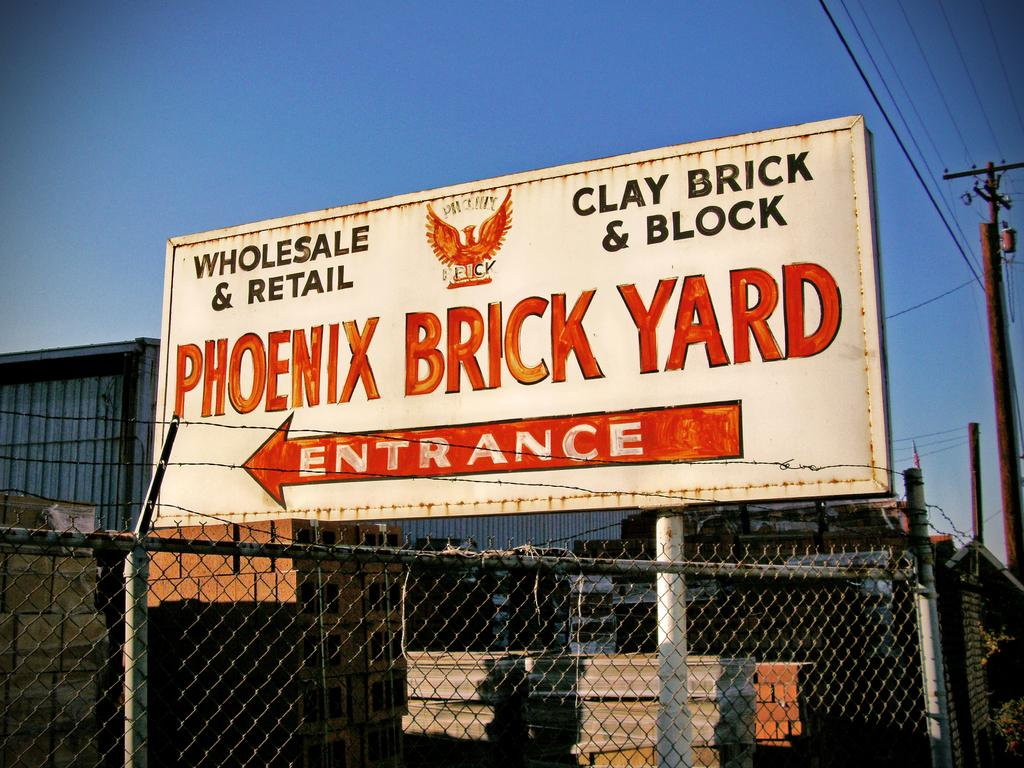Provide a one-sentence caption for the provided image. A large billboard is pointing the way to the entrance of the Phoenix Brick Yard. 